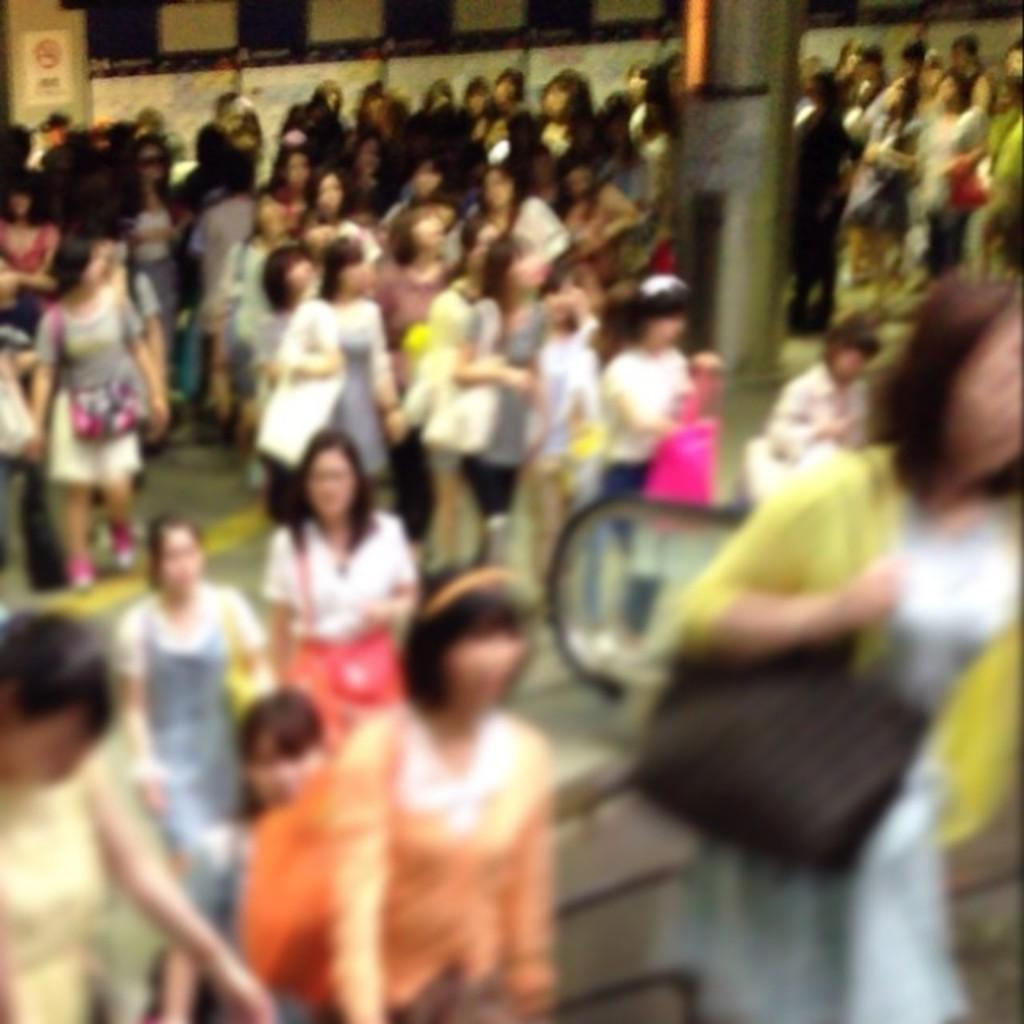How many women are present in the image? There are many women in the image. What are the women doing in the image? The women are standing and walking. What type of terrain is visible in the image? The land is visible in the image. What architectural feature can be seen on the right side of the image? There appears to be an escalator on the right side of the image. What is the tendency of the afterthought in the image? There is no afterthought present in the image. What position does the position hold in the image? There is no position present in the image. 